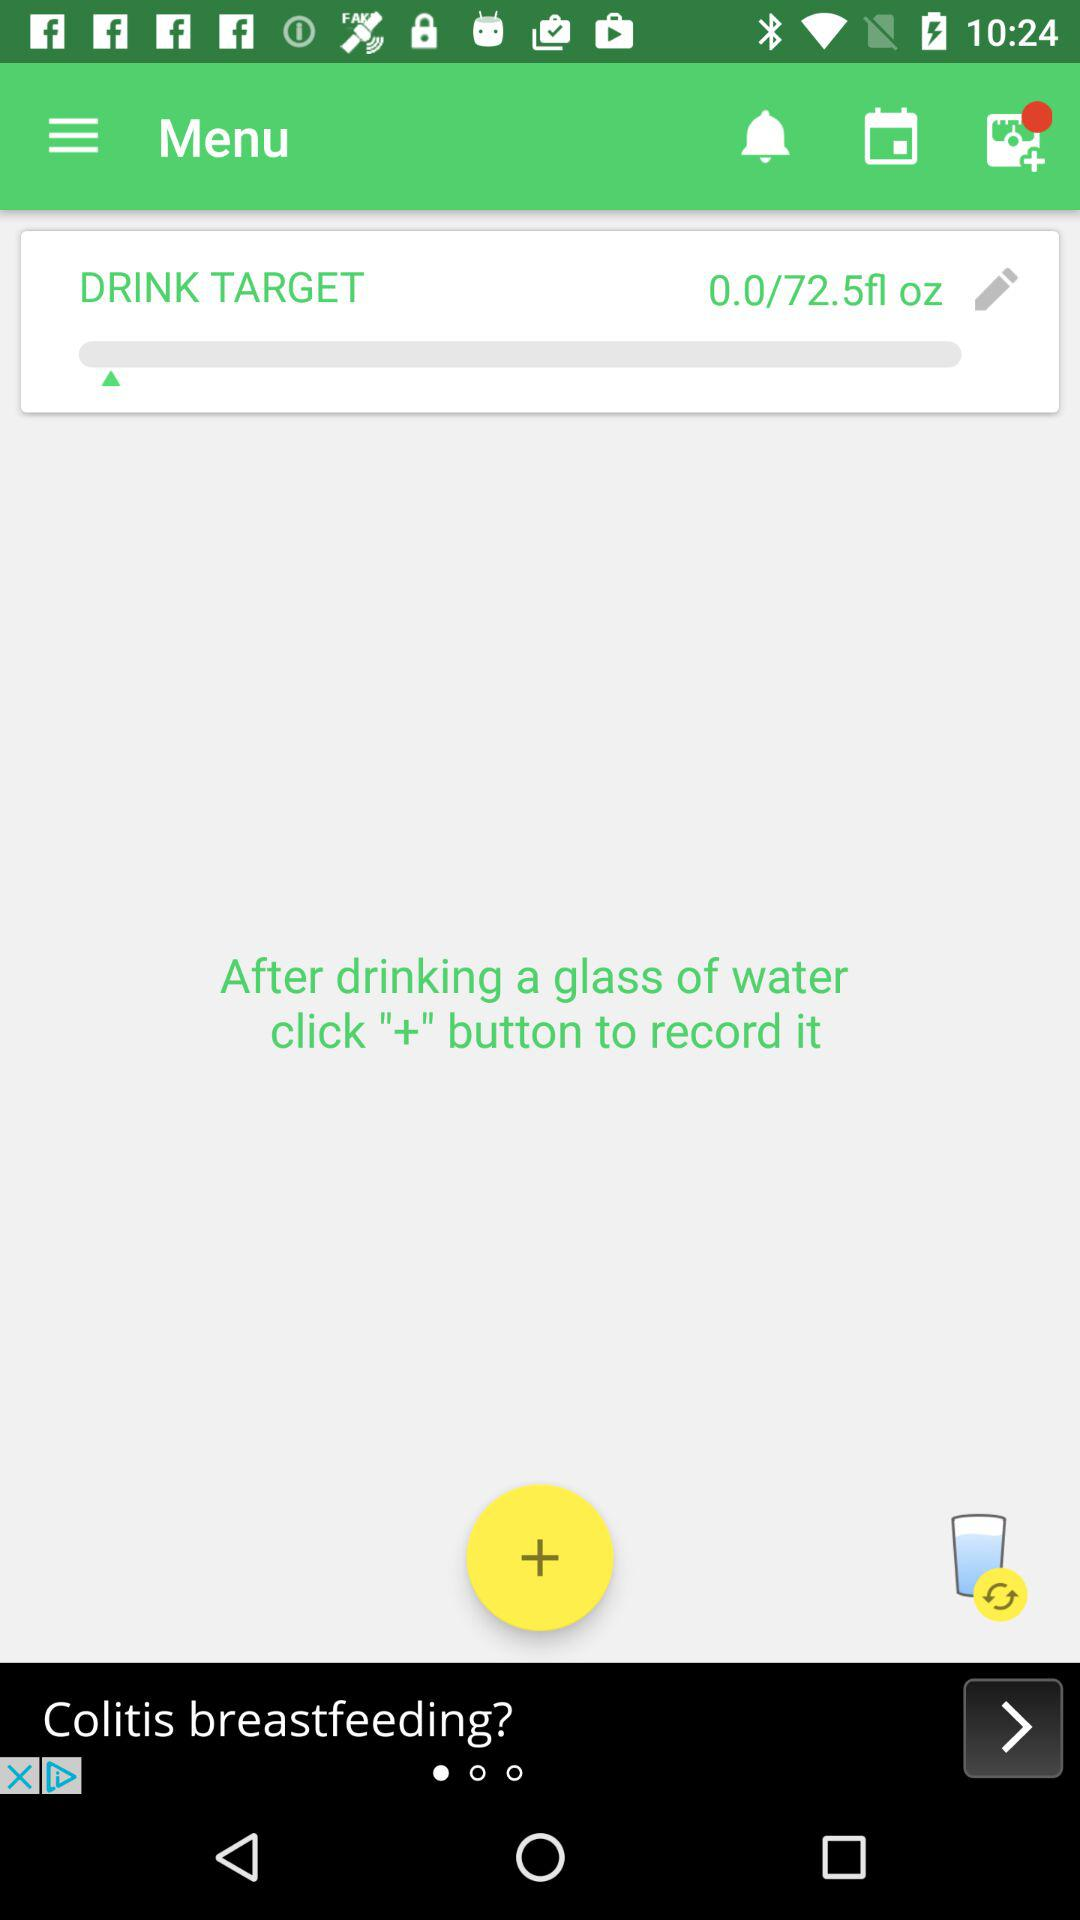How many more ounces do I need to drink to reach my goal?
Answer the question using a single word or phrase. 72.5 